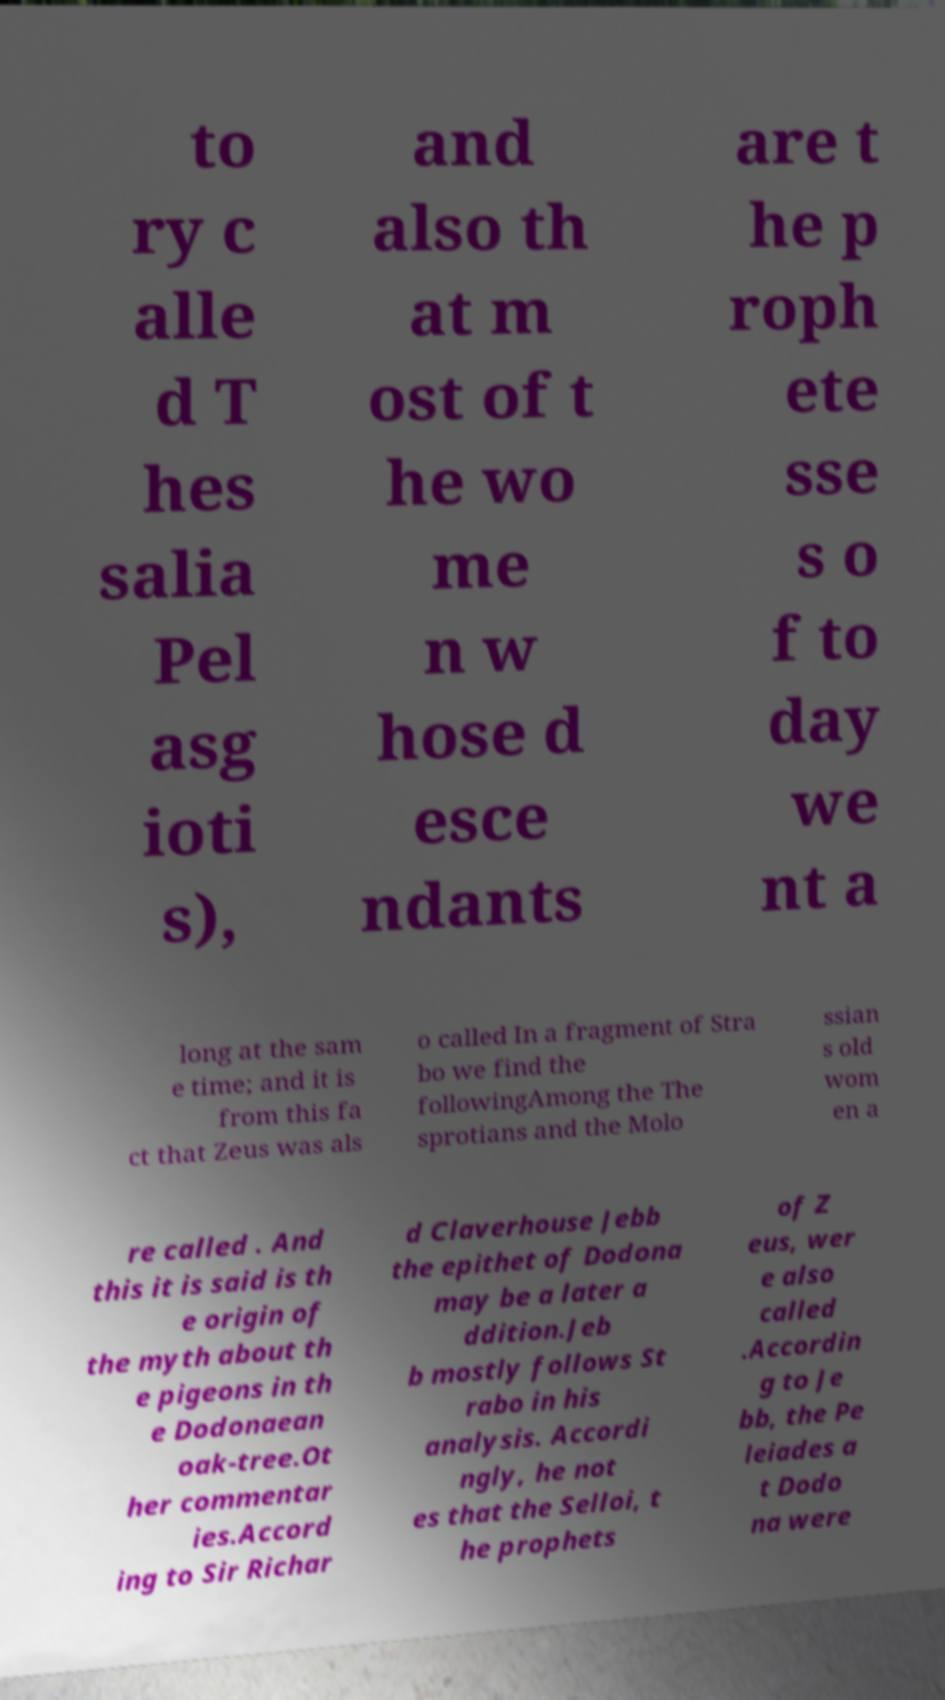Could you extract and type out the text from this image? to ry c alle d T hes salia Pel asg ioti s), and also th at m ost of t he wo me n w hose d esce ndants are t he p roph ete sse s o f to day we nt a long at the sam e time; and it is from this fa ct that Zeus was als o called In a fragment of Stra bo we find the followingAmong the The sprotians and the Molo ssian s old wom en a re called . And this it is said is th e origin of the myth about th e pigeons in th e Dodonaean oak-tree.Ot her commentar ies.Accord ing to Sir Richar d Claverhouse Jebb the epithet of Dodona may be a later a ddition.Jeb b mostly follows St rabo in his analysis. Accordi ngly, he not es that the Selloi, t he prophets of Z eus, wer e also called .Accordin g to Je bb, the Pe leiades a t Dodo na were 